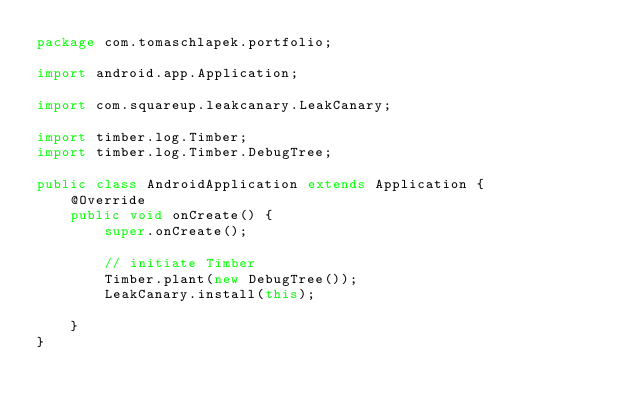Convert code to text. <code><loc_0><loc_0><loc_500><loc_500><_Java_>package com.tomaschlapek.portfolio;

import android.app.Application;

import com.squareup.leakcanary.LeakCanary;

import timber.log.Timber;
import timber.log.Timber.DebugTree;

public class AndroidApplication extends Application {
    @Override
    public void onCreate() {
        super.onCreate();

        // initiate Timber
        Timber.plant(new DebugTree());
        LeakCanary.install(this);

    }
}
</code> 